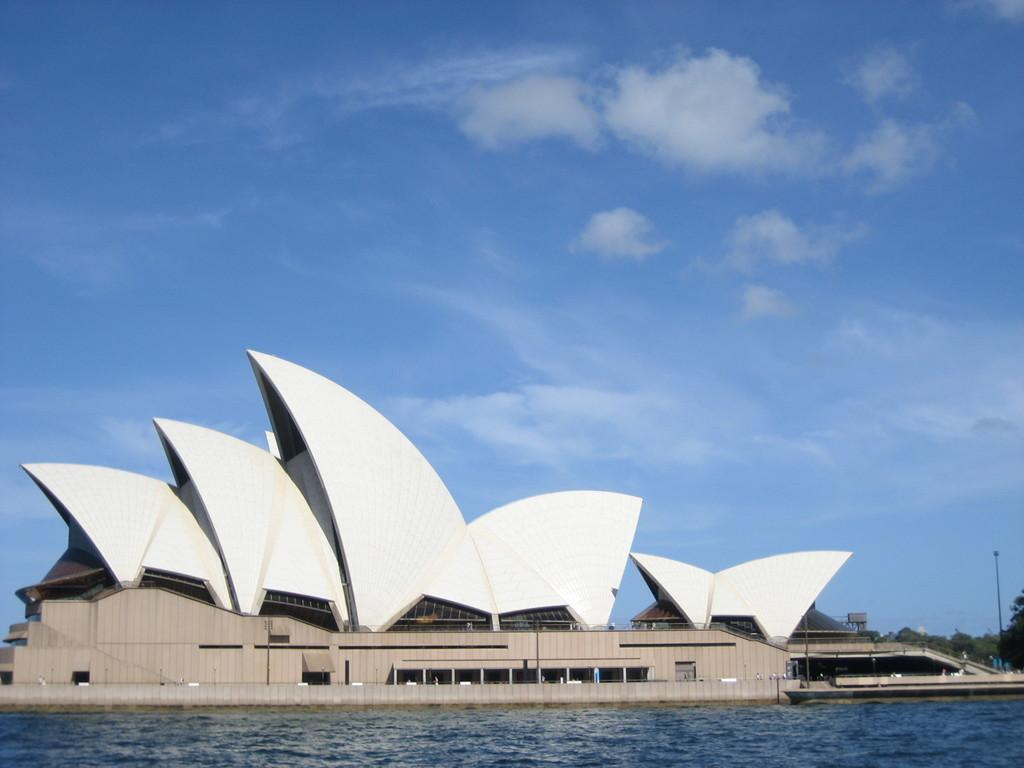What is the main subject of the image? The Sydney Opera House is visible in the image. What can be seen in the background of the image? There are trees, clouds, and the sky visible in the background of the image. What is the primary element in the image? There is water in the image. What relation does the queen have to the passenger in the image? There is no queen or passenger present in the image. 